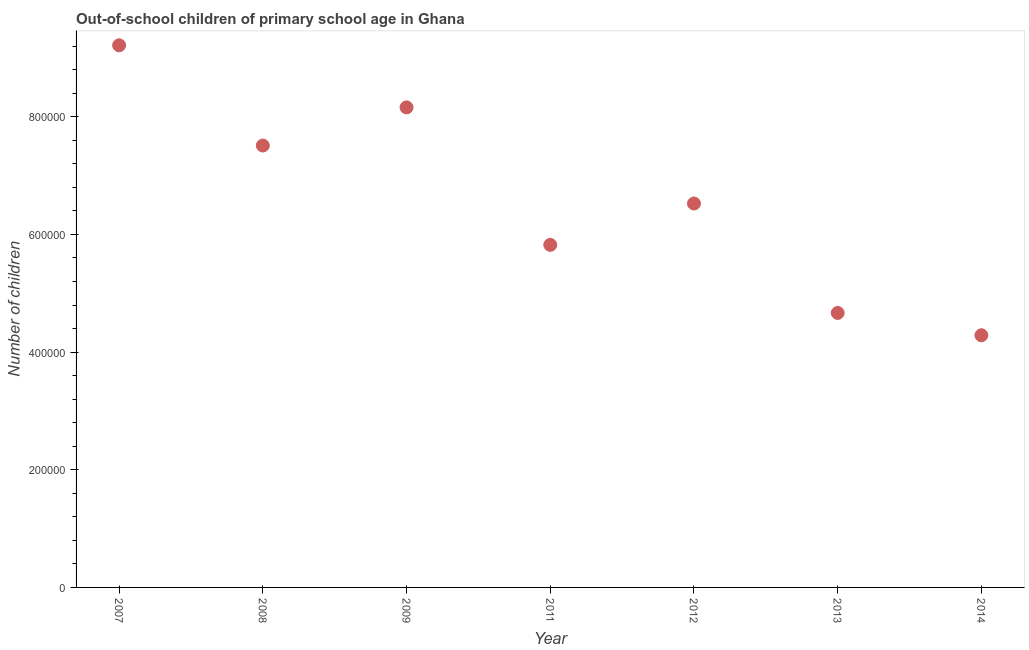What is the number of out-of-school children in 2008?
Make the answer very short. 7.51e+05. Across all years, what is the maximum number of out-of-school children?
Your answer should be compact. 9.21e+05. Across all years, what is the minimum number of out-of-school children?
Ensure brevity in your answer.  4.29e+05. What is the sum of the number of out-of-school children?
Your response must be concise. 4.62e+06. What is the difference between the number of out-of-school children in 2008 and 2013?
Your answer should be very brief. 2.85e+05. What is the average number of out-of-school children per year?
Offer a terse response. 6.60e+05. What is the median number of out-of-school children?
Offer a very short reply. 6.53e+05. What is the ratio of the number of out-of-school children in 2008 to that in 2009?
Give a very brief answer. 0.92. Is the number of out-of-school children in 2007 less than that in 2008?
Provide a succinct answer. No. What is the difference between the highest and the second highest number of out-of-school children?
Provide a succinct answer. 1.05e+05. Is the sum of the number of out-of-school children in 2011 and 2012 greater than the maximum number of out-of-school children across all years?
Your answer should be very brief. Yes. What is the difference between the highest and the lowest number of out-of-school children?
Provide a short and direct response. 4.93e+05. Does the number of out-of-school children monotonically increase over the years?
Offer a very short reply. No. How many dotlines are there?
Keep it short and to the point. 1. Are the values on the major ticks of Y-axis written in scientific E-notation?
Offer a very short reply. No. Does the graph contain any zero values?
Your answer should be very brief. No. What is the title of the graph?
Your answer should be compact. Out-of-school children of primary school age in Ghana. What is the label or title of the Y-axis?
Provide a short and direct response. Number of children. What is the Number of children in 2007?
Your answer should be compact. 9.21e+05. What is the Number of children in 2008?
Ensure brevity in your answer.  7.51e+05. What is the Number of children in 2009?
Your answer should be very brief. 8.16e+05. What is the Number of children in 2011?
Offer a terse response. 5.82e+05. What is the Number of children in 2012?
Keep it short and to the point. 6.53e+05. What is the Number of children in 2013?
Give a very brief answer. 4.67e+05. What is the Number of children in 2014?
Provide a succinct answer. 4.29e+05. What is the difference between the Number of children in 2007 and 2008?
Your response must be concise. 1.70e+05. What is the difference between the Number of children in 2007 and 2009?
Your answer should be very brief. 1.05e+05. What is the difference between the Number of children in 2007 and 2011?
Your answer should be compact. 3.39e+05. What is the difference between the Number of children in 2007 and 2012?
Make the answer very short. 2.69e+05. What is the difference between the Number of children in 2007 and 2013?
Offer a very short reply. 4.55e+05. What is the difference between the Number of children in 2007 and 2014?
Keep it short and to the point. 4.93e+05. What is the difference between the Number of children in 2008 and 2009?
Give a very brief answer. -6.48e+04. What is the difference between the Number of children in 2008 and 2011?
Offer a very short reply. 1.69e+05. What is the difference between the Number of children in 2008 and 2012?
Your answer should be very brief. 9.85e+04. What is the difference between the Number of children in 2008 and 2013?
Your answer should be compact. 2.85e+05. What is the difference between the Number of children in 2008 and 2014?
Give a very brief answer. 3.22e+05. What is the difference between the Number of children in 2009 and 2011?
Your response must be concise. 2.34e+05. What is the difference between the Number of children in 2009 and 2012?
Your response must be concise. 1.63e+05. What is the difference between the Number of children in 2009 and 2013?
Keep it short and to the point. 3.49e+05. What is the difference between the Number of children in 2009 and 2014?
Your answer should be very brief. 3.87e+05. What is the difference between the Number of children in 2011 and 2012?
Provide a succinct answer. -7.03e+04. What is the difference between the Number of children in 2011 and 2013?
Keep it short and to the point. 1.16e+05. What is the difference between the Number of children in 2011 and 2014?
Provide a short and direct response. 1.54e+05. What is the difference between the Number of children in 2012 and 2013?
Keep it short and to the point. 1.86e+05. What is the difference between the Number of children in 2012 and 2014?
Your answer should be compact. 2.24e+05. What is the difference between the Number of children in 2013 and 2014?
Offer a very short reply. 3.79e+04. What is the ratio of the Number of children in 2007 to that in 2008?
Keep it short and to the point. 1.23. What is the ratio of the Number of children in 2007 to that in 2009?
Provide a short and direct response. 1.13. What is the ratio of the Number of children in 2007 to that in 2011?
Keep it short and to the point. 1.58. What is the ratio of the Number of children in 2007 to that in 2012?
Your answer should be compact. 1.41. What is the ratio of the Number of children in 2007 to that in 2013?
Ensure brevity in your answer.  1.98. What is the ratio of the Number of children in 2007 to that in 2014?
Provide a succinct answer. 2.15. What is the ratio of the Number of children in 2008 to that in 2009?
Provide a short and direct response. 0.92. What is the ratio of the Number of children in 2008 to that in 2011?
Your answer should be very brief. 1.29. What is the ratio of the Number of children in 2008 to that in 2012?
Make the answer very short. 1.15. What is the ratio of the Number of children in 2008 to that in 2013?
Offer a very short reply. 1.61. What is the ratio of the Number of children in 2008 to that in 2014?
Offer a terse response. 1.75. What is the ratio of the Number of children in 2009 to that in 2011?
Give a very brief answer. 1.4. What is the ratio of the Number of children in 2009 to that in 2012?
Your response must be concise. 1.25. What is the ratio of the Number of children in 2009 to that in 2013?
Make the answer very short. 1.75. What is the ratio of the Number of children in 2009 to that in 2014?
Make the answer very short. 1.9. What is the ratio of the Number of children in 2011 to that in 2012?
Offer a very short reply. 0.89. What is the ratio of the Number of children in 2011 to that in 2013?
Make the answer very short. 1.25. What is the ratio of the Number of children in 2011 to that in 2014?
Keep it short and to the point. 1.36. What is the ratio of the Number of children in 2012 to that in 2013?
Ensure brevity in your answer.  1.4. What is the ratio of the Number of children in 2012 to that in 2014?
Offer a terse response. 1.52. What is the ratio of the Number of children in 2013 to that in 2014?
Keep it short and to the point. 1.09. 